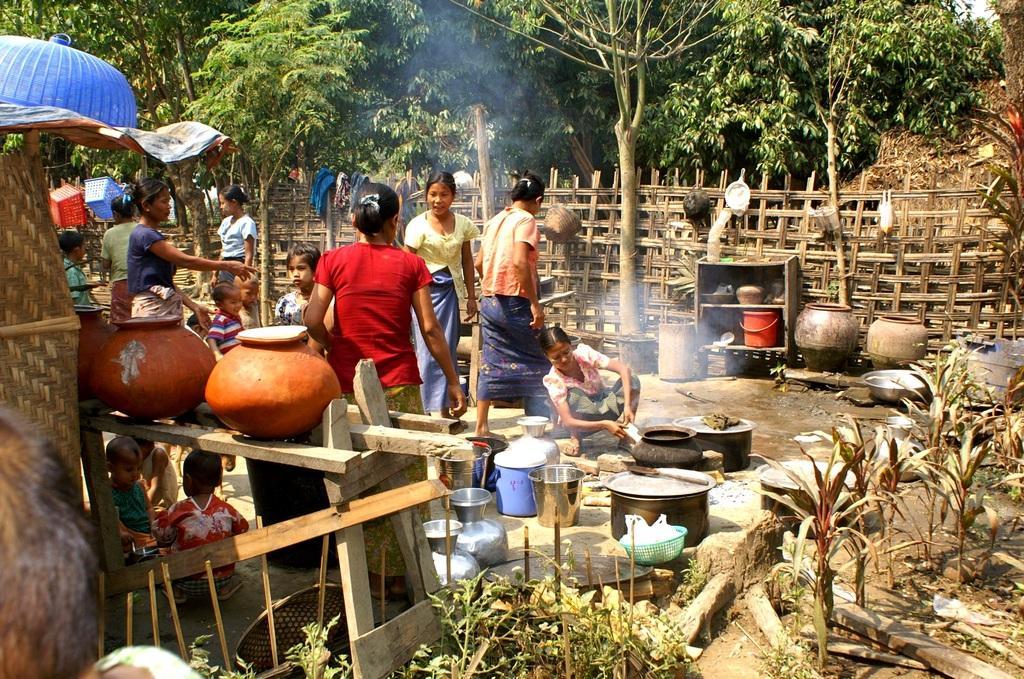Describe this image in one or two sentences. In the image there are many utensils and a woman is cooking something and behind her there are many people, there is a fence around them and behind the fence there are many trees. 